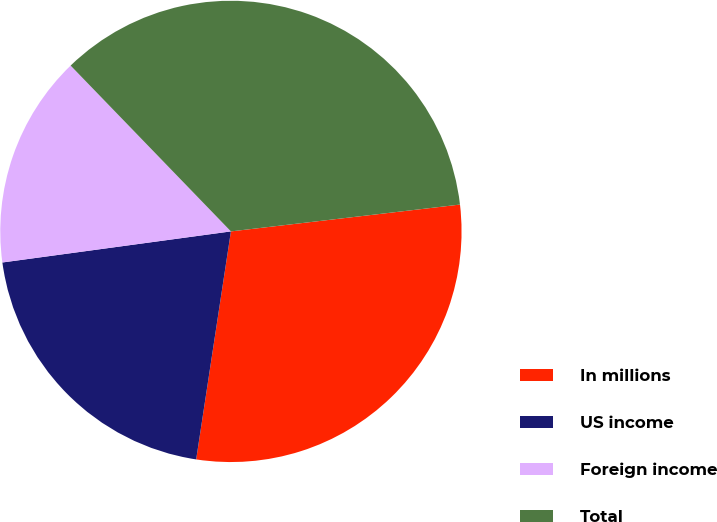Convert chart to OTSL. <chart><loc_0><loc_0><loc_500><loc_500><pie_chart><fcel>In millions<fcel>US income<fcel>Foreign income<fcel>Total<nl><fcel>29.26%<fcel>20.44%<fcel>14.92%<fcel>35.37%<nl></chart> 